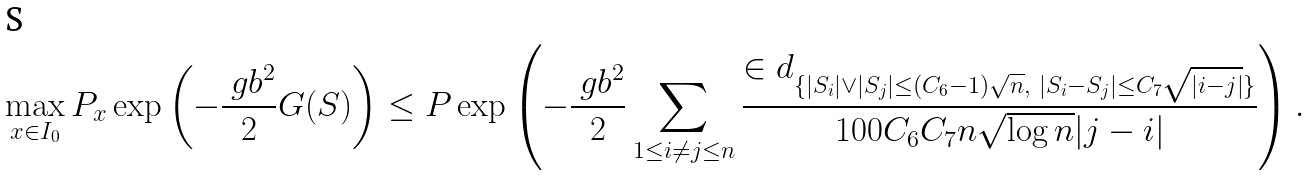Convert formula to latex. <formula><loc_0><loc_0><loc_500><loc_500>\max _ { x \in I _ { 0 } } P _ { x } \exp \left ( - \frac { \ g b ^ { 2 } } { 2 } G ( S ) \right ) \leq P \exp \left ( - \frac { \ g b ^ { 2 } } { 2 } \sum _ { 1 \leq i \neq j \leq n } \frac { \in d _ { \{ | S _ { i } | \vee | S _ { j } | \leq ( C _ { 6 } - 1 ) \sqrt { n } , \ | S _ { i } - S _ { j } | \leq C _ { 7 } \sqrt { | i - j | } \} } } { 1 0 0 C _ { 6 } C _ { 7 } n \sqrt { \log n } | j - i | } \right ) .</formula> 